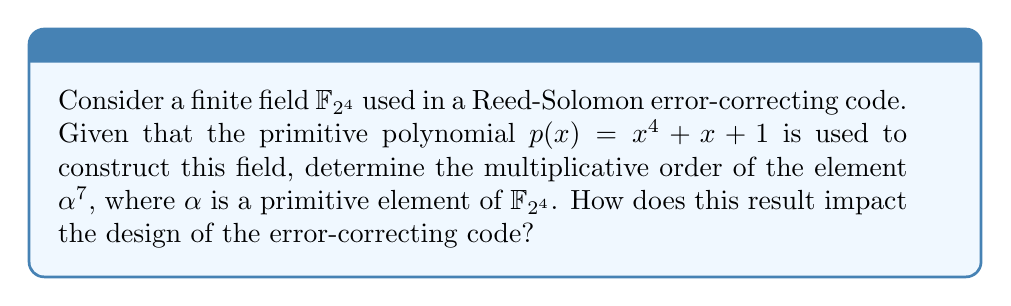Provide a solution to this math problem. To solve this problem, we'll follow these steps:

1) In $\mathbb{F}_{2^4}$, the multiplicative group has order $2^4 - 1 = 15$.

2) The primitive element $\alpha$ has multiplicative order 15, as it generates the entire multiplicative group.

3) To find the order of $\alpha^7$, we need to find the smallest positive integer $k$ such that $(\alpha^7)^k = 1$.

4) This is equivalent to finding the smallest $k$ such that $7k \equiv 0 \pmod{15}$.

5) We can solve this using the concept of multiplicative order in modular arithmetic:
   $\text{ord}_{15}(7) = 4$ because $7^4 \equiv 1 \pmod{15}$ and 4 is the smallest such positive integer.

6) Therefore, the multiplicative order of $\alpha^7$ is 4.

7) In the context of Reed-Solomon codes, this result impacts the design as follows:
   - The element $\alpha^7$ can be used to generate a cyclic subgroup of order 4 in $\mathbb{F}_{2^4}$.
   - This subgroup can be utilized to construct a shorter cyclic code, which might be useful for specific applications requiring less redundancy.
   - However, using $\alpha^7$ instead of $\alpha$ would limit the maximum code length to 4 symbols, reducing the error-correcting capability compared to using the full field.

8) The choice between using $\alpha$ or $\alpha^7$ as a generator element would depend on the specific requirements of the error-correcting code, balancing factors such as code length, redundancy, and error-correcting capability.
Answer: 4 